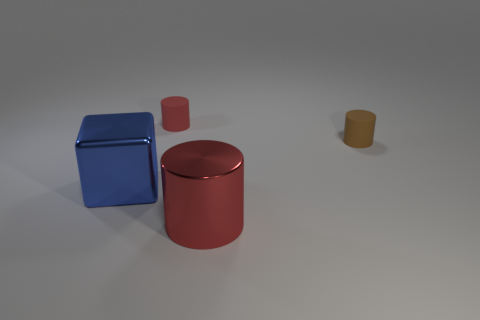Is there another cylinder made of the same material as the tiny red cylinder?
Your response must be concise. Yes. There is a thing that is the same size as the red rubber cylinder; what is it made of?
Your answer should be very brief. Rubber. What number of big red things have the same shape as the small brown thing?
Provide a succinct answer. 1. There is a brown cylinder that is made of the same material as the small red cylinder; what is its size?
Keep it short and to the point. Small. What material is the thing that is to the left of the brown cylinder and on the right side of the small red thing?
Your answer should be very brief. Metal. What number of red metal objects are the same size as the blue cube?
Provide a short and direct response. 1. There is a tiny red thing that is the same shape as the small brown matte thing; what is its material?
Ensure brevity in your answer.  Rubber. What number of objects are objects in front of the big blue block or cylinders behind the red metallic thing?
Make the answer very short. 3. There is a brown matte thing; does it have the same shape as the metallic object on the right side of the tiny red cylinder?
Your response must be concise. Yes. There is a rubber thing left of the rubber thing that is in front of the rubber thing on the left side of the brown cylinder; what shape is it?
Make the answer very short. Cylinder. 